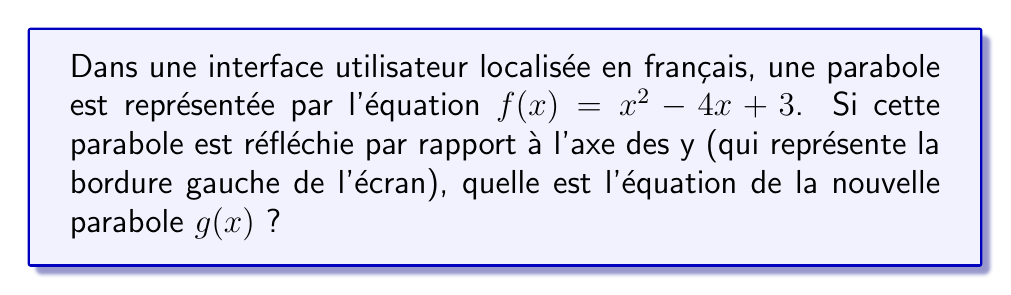Provide a solution to this math problem. Pour réfléchir une parabole par rapport à l'axe des y, nous suivons ces étapes :

1. L'équation générale d'une parabole est $f(x) = ax^2 + bx + c$.
   Dans notre cas, $a=1$, $b=-4$, et $c=3$.

2. La réflexion par rapport à l'axe des y transforme $x$ en $-x$.

3. Remplaçons $x$ par $-x$ dans l'équation originale :
   $g(x) = (-x)^2 - 4(-x) + 3$

4. Simplifions :
   $g(x) = x^2 + 4x + 3$

5. L'équation finale de la parabole réfléchie est donc :
   $g(x) = x^2 + 4x + 3$

Notez que le coefficient de $x^2$ reste inchangé, le coefficient de $x$ change de signe, et le terme constant reste le même.
Answer: $g(x) = x^2 + 4x + 3$ 